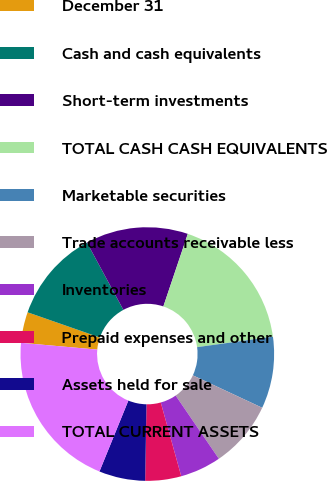Convert chart to OTSL. <chart><loc_0><loc_0><loc_500><loc_500><pie_chart><fcel>December 31<fcel>Cash and cash equivalents<fcel>Short-term investments<fcel>TOTAL CASH CASH EQUIVALENTS<fcel>Marketable securities<fcel>Trade accounts receivable less<fcel>Inventories<fcel>Prepaid expenses and other<fcel>Assets held for sale<fcel>TOTAL CURRENT ASSETS<nl><fcel>3.93%<fcel>11.76%<fcel>13.07%<fcel>17.64%<fcel>9.15%<fcel>8.5%<fcel>5.23%<fcel>4.58%<fcel>5.89%<fcel>20.25%<nl></chart> 